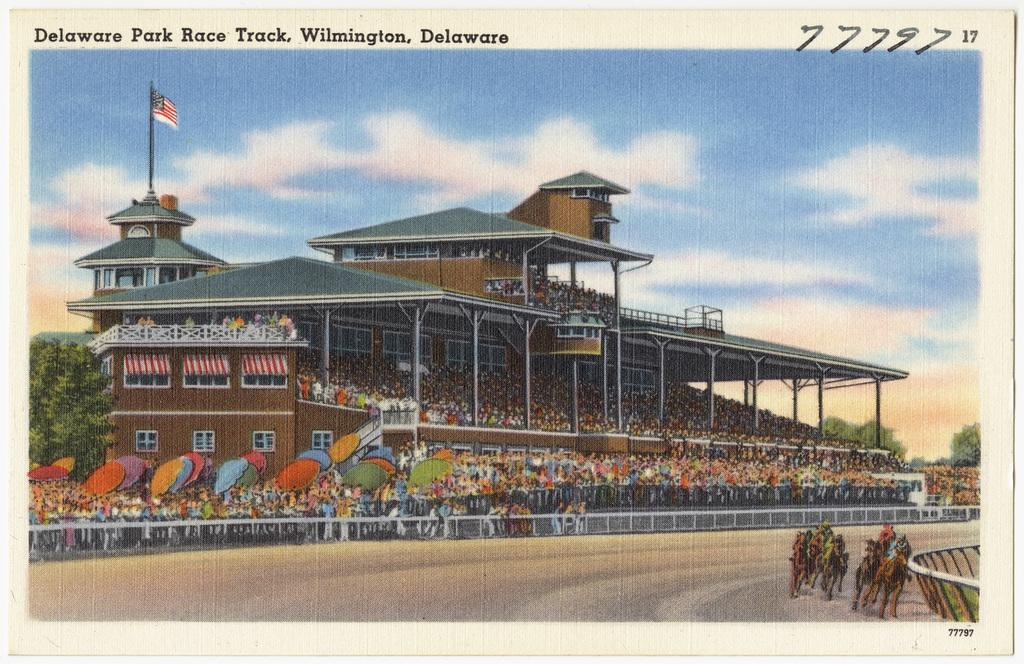What is present in the image that contains both images and text? There is a poster in the image that contains images and text. What type of wool is used to create the images on the poster? There is no wool mentioned or depicted in the image, as the poster contains images and text, not wool. 